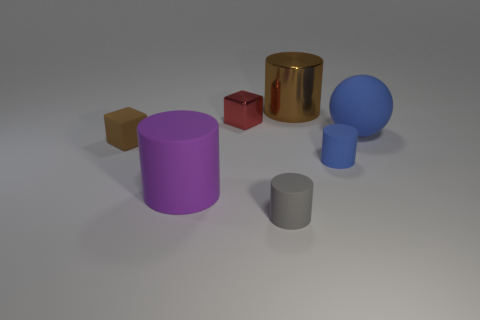What number of objects are large objects behind the matte block or big matte objects to the left of the tiny gray rubber object?
Offer a very short reply. 3. Are there any small things to the left of the red object?
Ensure brevity in your answer.  Yes. There is a big matte thing that is right of the block behind the tiny object left of the big purple cylinder; what color is it?
Keep it short and to the point. Blue. Does the tiny blue rubber thing have the same shape as the small brown rubber thing?
Offer a very short reply. No. There is a cube that is made of the same material as the large brown thing; what color is it?
Offer a terse response. Red. How many objects are either matte cylinders to the left of the brown cylinder or small matte things?
Your answer should be very brief. 4. There is a cylinder behind the red metallic cube; what is its size?
Your response must be concise. Large. Do the metal cube and the rubber ball behind the gray thing have the same size?
Your response must be concise. No. What color is the large matte thing in front of the tiny block that is left of the tiny red cube?
Provide a succinct answer. Purple. What number of other things are the same color as the large rubber ball?
Give a very brief answer. 1. 